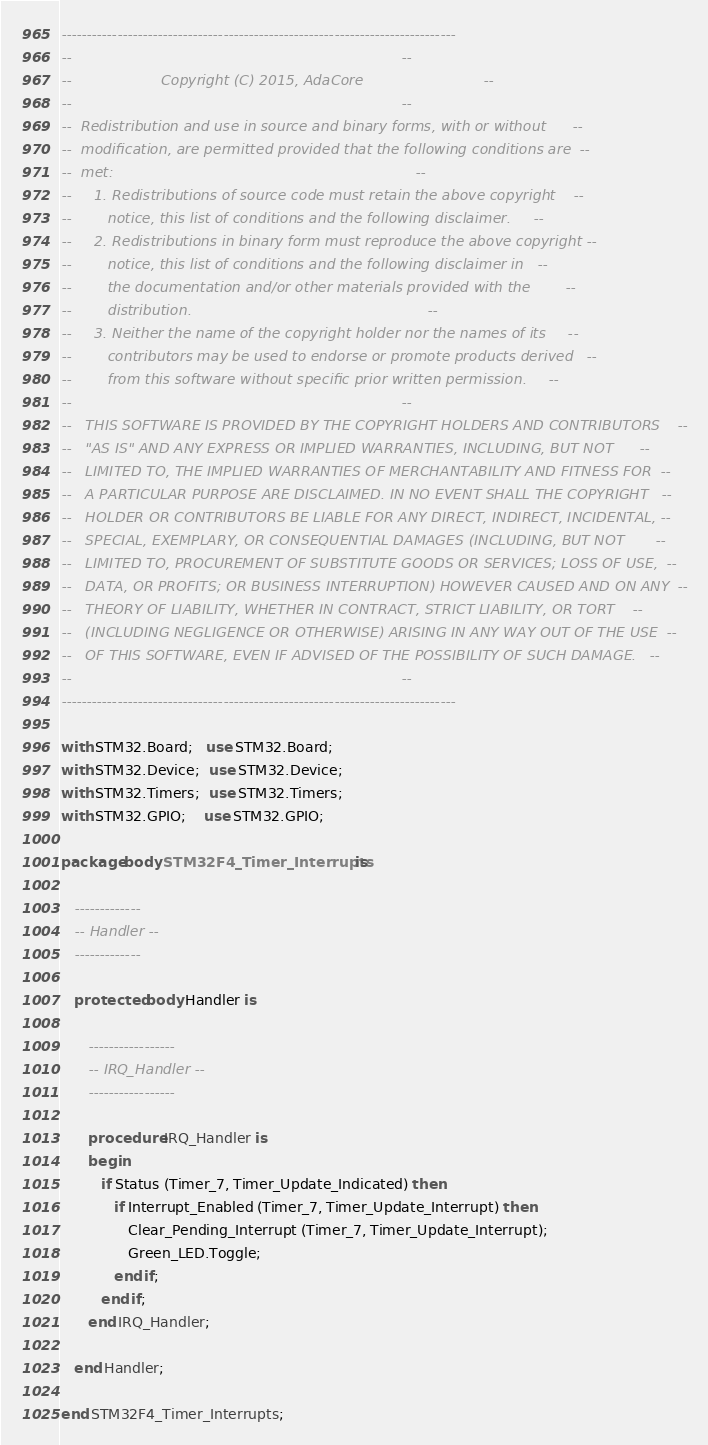<code> <loc_0><loc_0><loc_500><loc_500><_Ada_>------------------------------------------------------------------------------
--                                                                          --
--                    Copyright (C) 2015, AdaCore                           --
--                                                                          --
--  Redistribution and use in source and binary forms, with or without      --
--  modification, are permitted provided that the following conditions are  --
--  met:                                                                    --
--     1. Redistributions of source code must retain the above copyright    --
--        notice, this list of conditions and the following disclaimer.     --
--     2. Redistributions in binary form must reproduce the above copyright --
--        notice, this list of conditions and the following disclaimer in   --
--        the documentation and/or other materials provided with the        --
--        distribution.                                                     --
--     3. Neither the name of the copyright holder nor the names of its     --
--        contributors may be used to endorse or promote products derived   --
--        from this software without specific prior written permission.     --
--                                                                          --
--   THIS SOFTWARE IS PROVIDED BY THE COPYRIGHT HOLDERS AND CONTRIBUTORS    --
--   "AS IS" AND ANY EXPRESS OR IMPLIED WARRANTIES, INCLUDING, BUT NOT      --
--   LIMITED TO, THE IMPLIED WARRANTIES OF MERCHANTABILITY AND FITNESS FOR  --
--   A PARTICULAR PURPOSE ARE DISCLAIMED. IN NO EVENT SHALL THE COPYRIGHT   --
--   HOLDER OR CONTRIBUTORS BE LIABLE FOR ANY DIRECT, INDIRECT, INCIDENTAL, --
--   SPECIAL, EXEMPLARY, OR CONSEQUENTIAL DAMAGES (INCLUDING, BUT NOT       --
--   LIMITED TO, PROCUREMENT OF SUBSTITUTE GOODS OR SERVICES; LOSS OF USE,  --
--   DATA, OR PROFITS; OR BUSINESS INTERRUPTION) HOWEVER CAUSED AND ON ANY  --
--   THEORY OF LIABILITY, WHETHER IN CONTRACT, STRICT LIABILITY, OR TORT    --
--   (INCLUDING NEGLIGENCE OR OTHERWISE) ARISING IN ANY WAY OUT OF THE USE  --
--   OF THIS SOFTWARE, EVEN IF ADVISED OF THE POSSIBILITY OF SUCH DAMAGE.   --
--                                                                          --
------------------------------------------------------------------------------

with STM32.Board;   use STM32.Board;
with STM32.Device;  use STM32.Device;
with STM32.Timers;  use STM32.Timers;
with STM32.GPIO;    use STM32.GPIO;

package body STM32F4_Timer_Interrupts is

   -------------
   -- Handler --
   -------------

   protected body Handler is

      -----------------
      -- IRQ_Handler --
      -----------------

      procedure IRQ_Handler is
      begin
         if Status (Timer_7, Timer_Update_Indicated) then
            if Interrupt_Enabled (Timer_7, Timer_Update_Interrupt) then
               Clear_Pending_Interrupt (Timer_7, Timer_Update_Interrupt);
               Green_LED.Toggle;
            end if;
         end if;
      end IRQ_Handler;

   end Handler;

end STM32F4_Timer_Interrupts;
</code> 